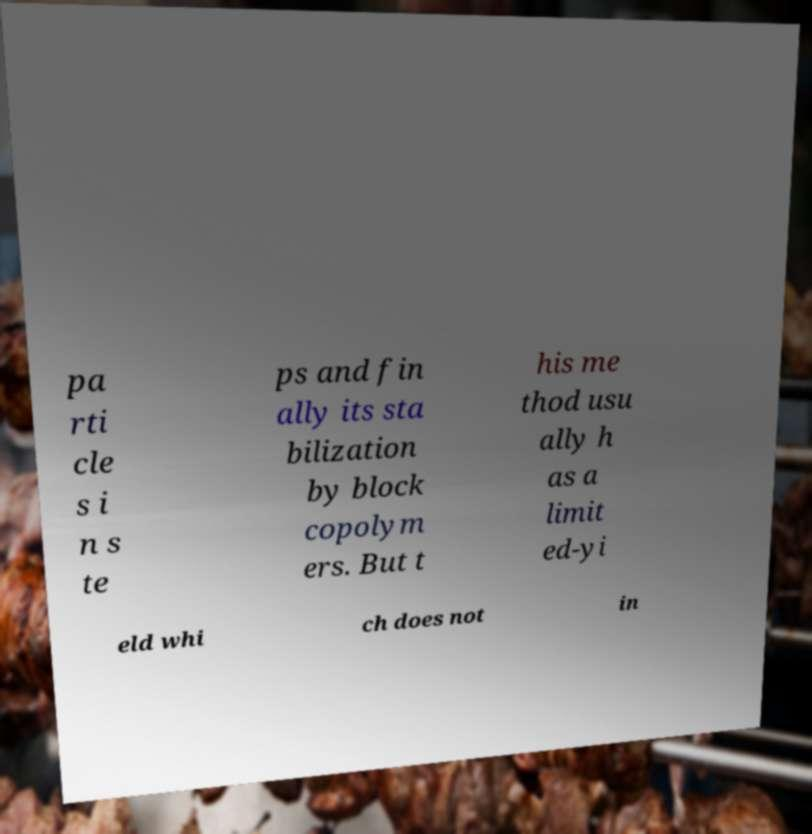Can you read and provide the text displayed in the image?This photo seems to have some interesting text. Can you extract and type it out for me? pa rti cle s i n s te ps and fin ally its sta bilization by block copolym ers. But t his me thod usu ally h as a limit ed-yi eld whi ch does not in 